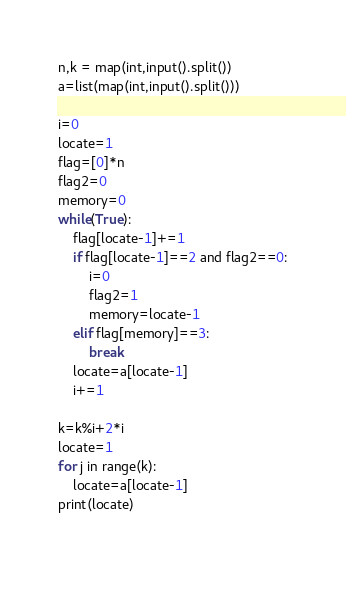Convert code to text. <code><loc_0><loc_0><loc_500><loc_500><_Python_>n,k = map(int,input().split())
a=list(map(int,input().split()))

i=0
locate=1
flag=[0]*n
flag2=0
memory=0
while(True):
    flag[locate-1]+=1
    if flag[locate-1]==2 and flag2==0:
        i=0
        flag2=1
        memory=locate-1
    elif flag[memory]==3:
        break
    locate=a[locate-1]
    i+=1

k=k%i+2*i
locate=1
for j in range(k):
    locate=a[locate-1]
print(locate)
    </code> 